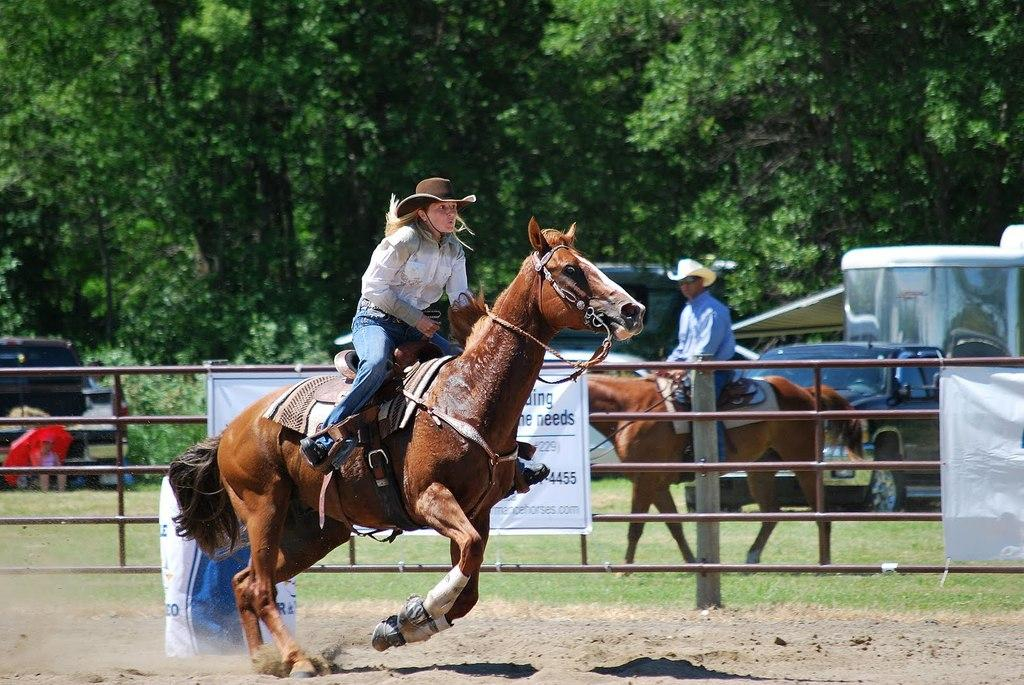How many people are on the horse in the image? There are two persons on a horse in the image. What type of vegetation is present in the image? There is grass in the image. What else can be seen in the image besides the horse and people? There are vehicles visible in the image. What is visible in the background of the image? There are trees and a banner in the background of the image. Can you see a squirrel playing on the banner in the image? There is no squirrel present in the image, and the banner does not show any signs of play. 